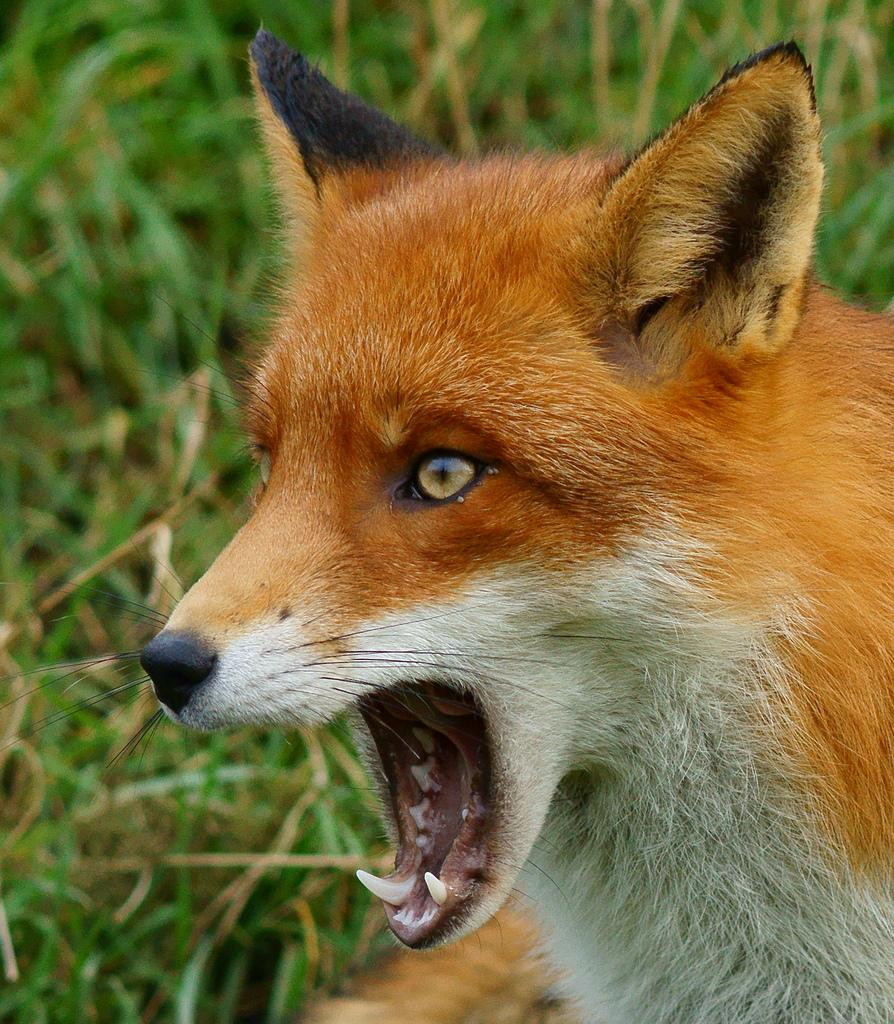What type of animal is in the picture? The animal in the picture is not specified, but it has white and orange colors. Can you describe the colors of the animal? The animal has white and orange colors. What can be seen in the background of the picture? There is grass visible in the background of the picture. What type of leather is used to make the animal's collar in the image? There is no mention of a collar or leather in the image, as it only features an animal with white and orange colors and grass in the background. 